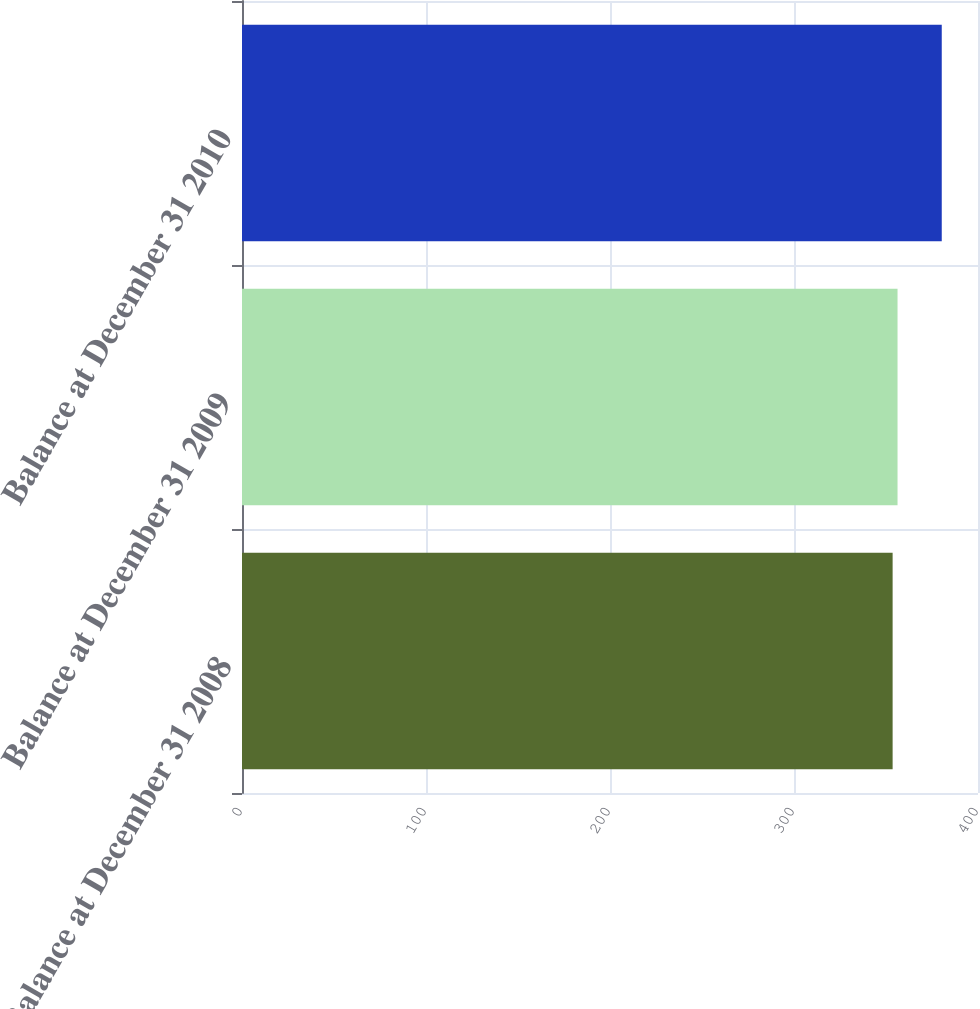Convert chart to OTSL. <chart><loc_0><loc_0><loc_500><loc_500><bar_chart><fcel>Balance at December 31 2008<fcel>Balance at December 31 2009<fcel>Balance at December 31 2010<nl><fcel>353.6<fcel>356.27<fcel>380.3<nl></chart> 